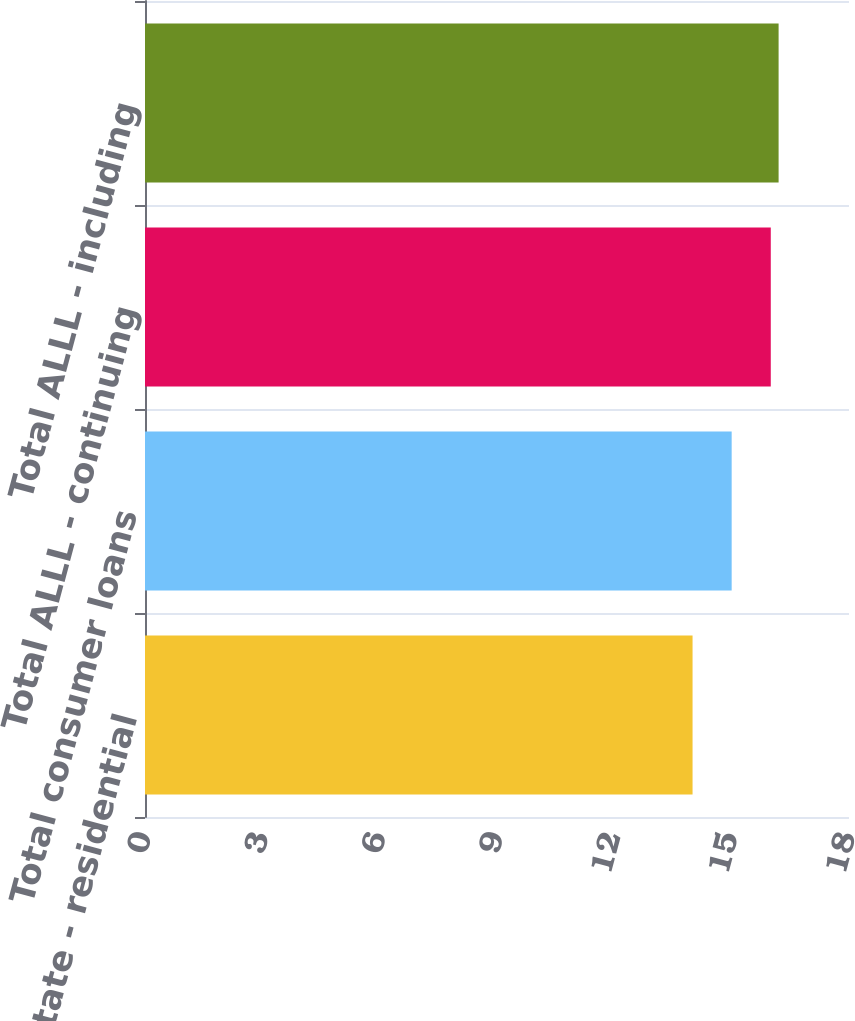Convert chart. <chart><loc_0><loc_0><loc_500><loc_500><bar_chart><fcel>Real estate - residential<fcel>Total consumer loans<fcel>Total ALLL - continuing<fcel>Total ALLL - including<nl><fcel>14<fcel>15<fcel>16<fcel>16.2<nl></chart> 